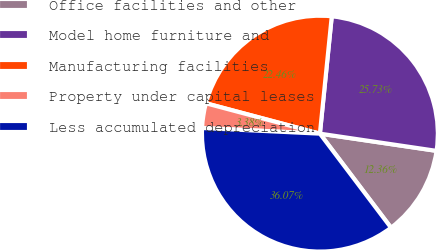Convert chart. <chart><loc_0><loc_0><loc_500><loc_500><pie_chart><fcel>Office facilities and other<fcel>Model home furniture and<fcel>Manufacturing facilities<fcel>Property under capital leases<fcel>Less accumulated depreciation<nl><fcel>12.36%<fcel>25.73%<fcel>22.46%<fcel>3.38%<fcel>36.07%<nl></chart> 